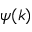Convert formula to latex. <formula><loc_0><loc_0><loc_500><loc_500>\psi ( k )</formula> 